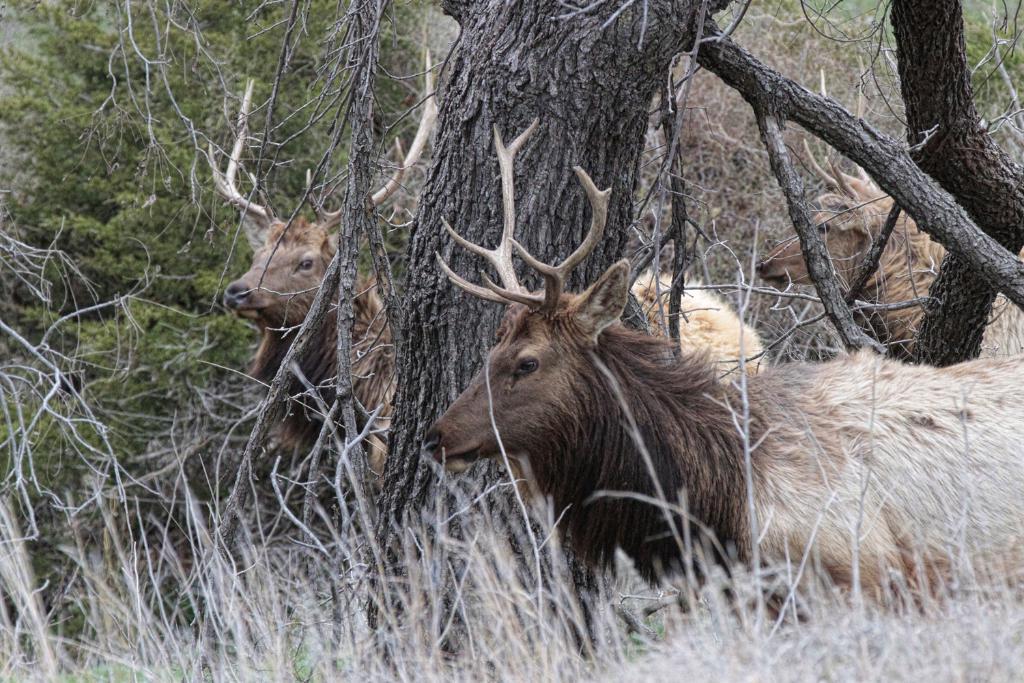Can you describe this image briefly? In this image we can see some animals on the ground. We can also see the bark of the trees, some plants and trees. 